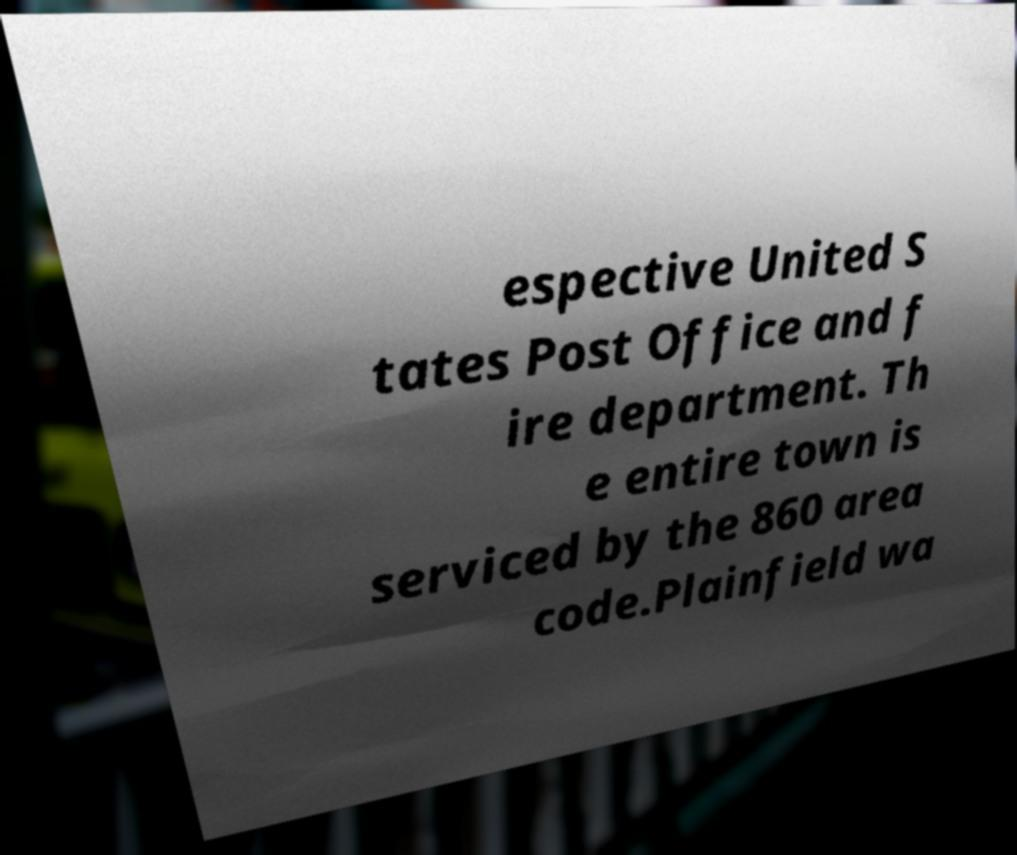Could you assist in decoding the text presented in this image and type it out clearly? espective United S tates Post Office and f ire department. Th e entire town is serviced by the 860 area code.Plainfield wa 